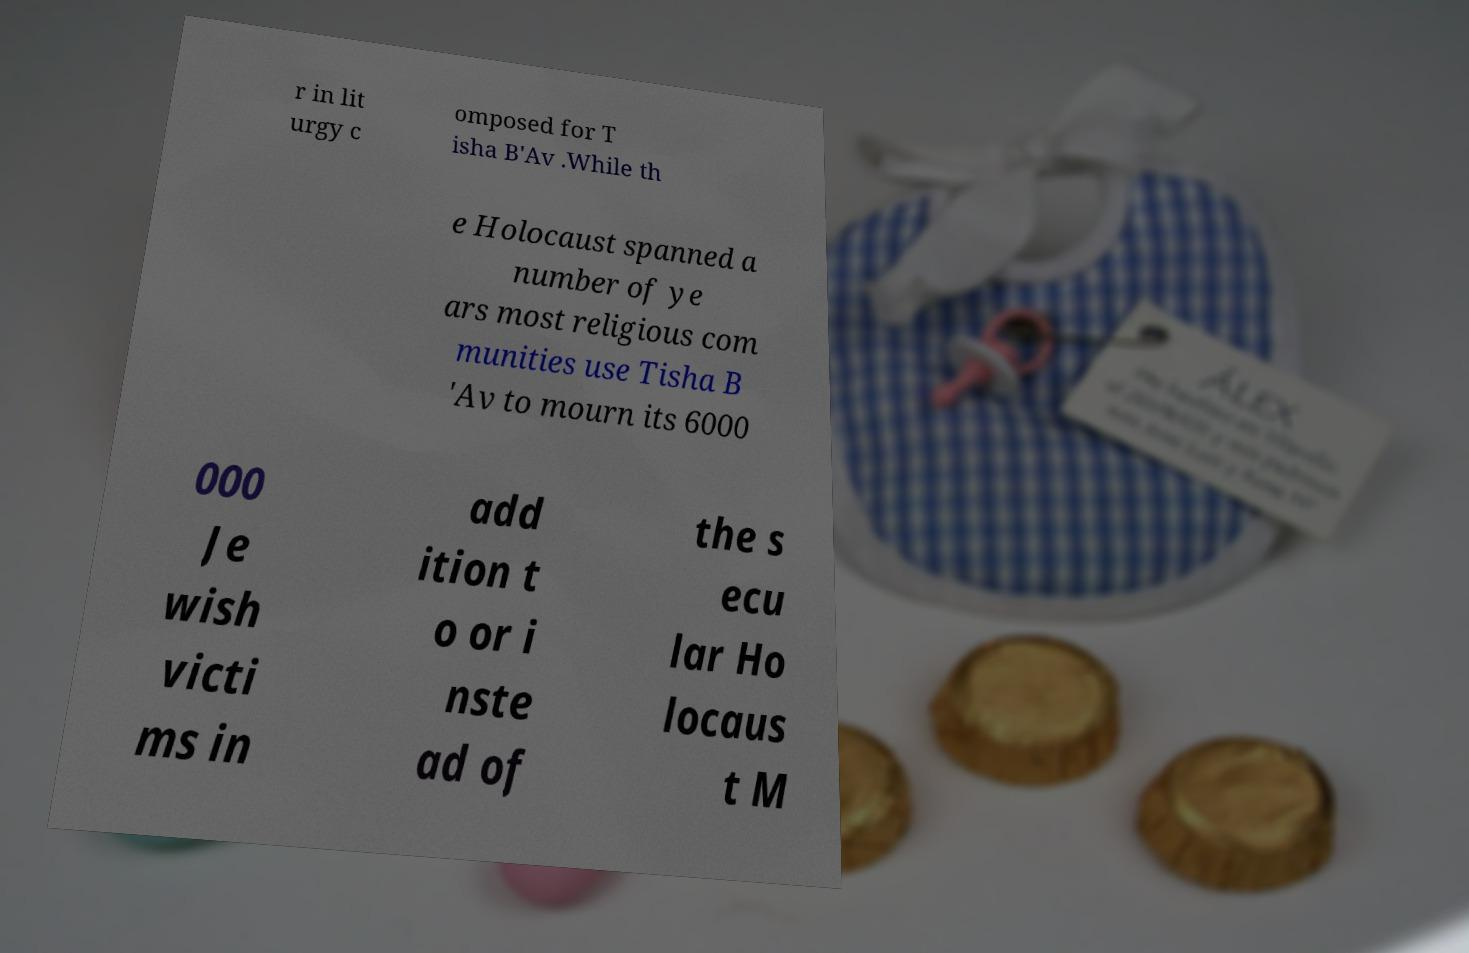Could you assist in decoding the text presented in this image and type it out clearly? r in lit urgy c omposed for T isha B'Av .While th e Holocaust spanned a number of ye ars most religious com munities use Tisha B 'Av to mourn its 6000 000 Je wish victi ms in add ition t o or i nste ad of the s ecu lar Ho locaus t M 